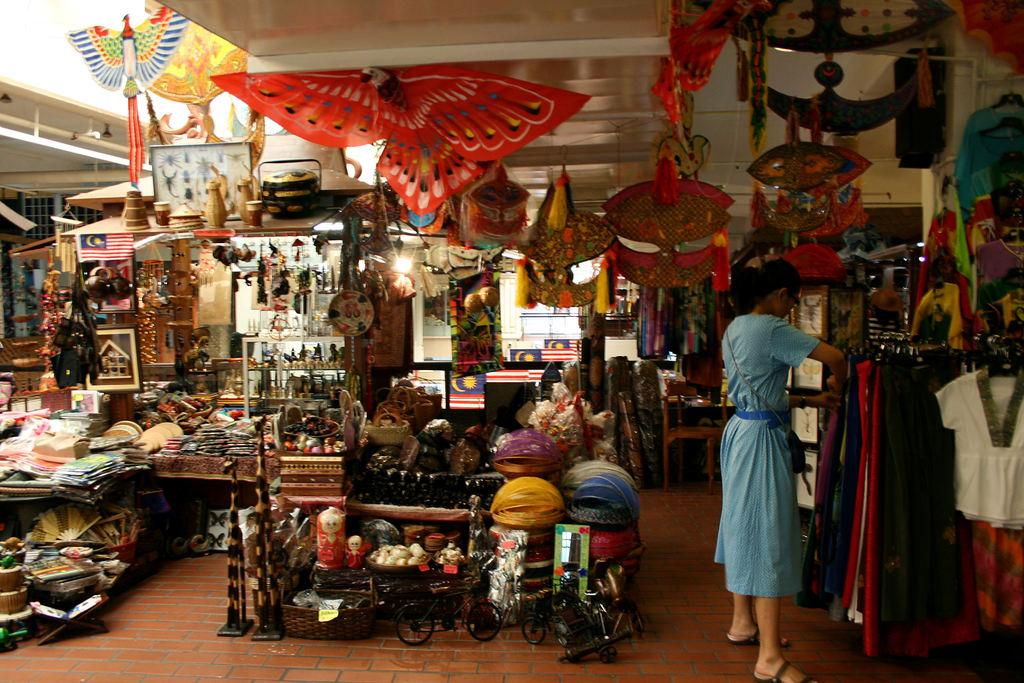What type of establishment is depicted in the image? The image shows a view of a novelty shop. What can be seen hanging in the front of the shop? There are decorative hanging clothes in the front of the shop. What type of vehicles are present in the front of the shop? There are iron three-wheel cycles in the front of the shop. What musical instrument is present in the shop? A flute is present in the shop. What type of items can be found in the shop? There are toys in the shop. Can you tell me how many squirrels are sitting on the flute in the image? There are no squirrels present in the image, and therefore none are sitting on the flute. What type of nails are used to hold the iron three-wheel cycles in place? The image does not provide information about the type of nails used to hold the iron three-wheel cycles in place. 